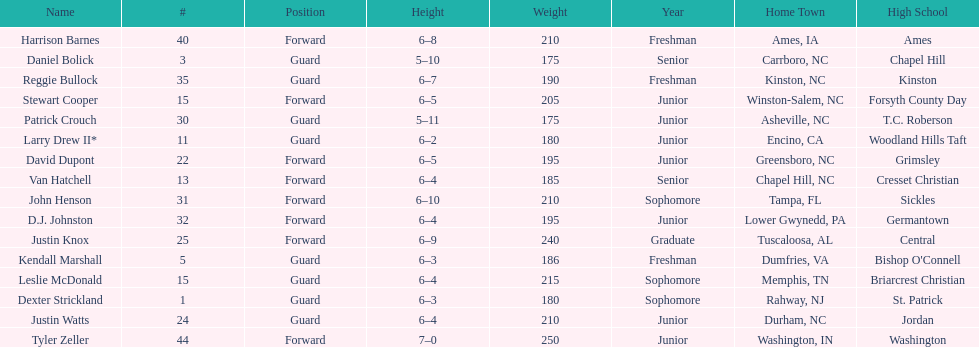How many players are not a youth? 9. 